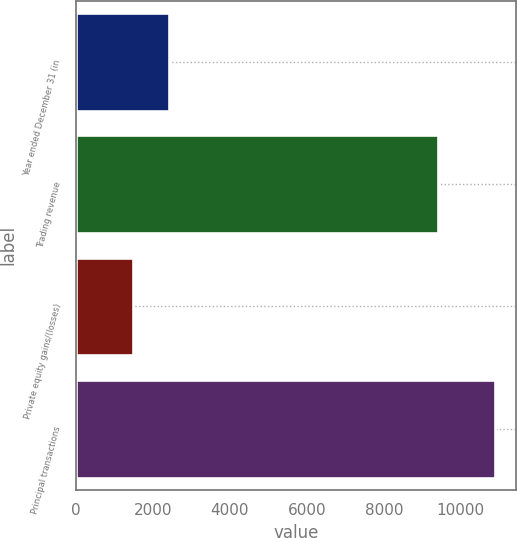Convert chart to OTSL. <chart><loc_0><loc_0><loc_500><loc_500><bar_chart><fcel>Year ended December 31 (in<fcel>Trading revenue<fcel>Private equity gains/(losses)<fcel>Principal transactions<nl><fcel>2430.4<fcel>9404<fcel>1490<fcel>10894<nl></chart> 